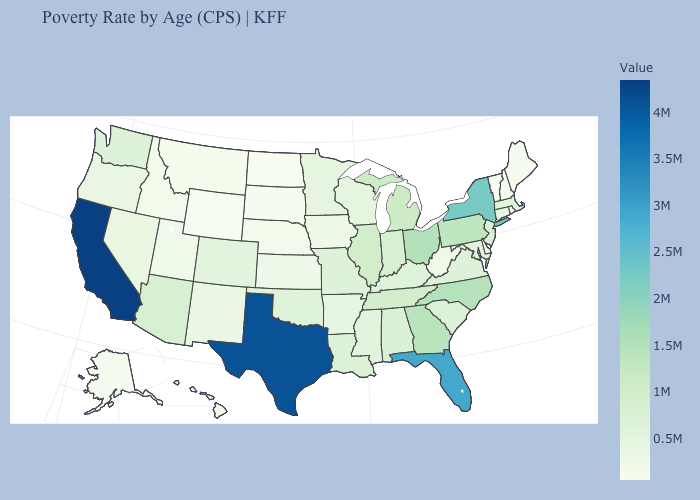Among the states that border Maryland , does Pennsylvania have the highest value?
Keep it brief. Yes. Does Colorado have the highest value in the West?
Give a very brief answer. No. Among the states that border Georgia , does Florida have the highest value?
Keep it brief. Yes. Does California have the highest value in the West?
Write a very short answer. Yes. Does North Dakota have a lower value than California?
Keep it brief. Yes. Among the states that border Massachusetts , which have the lowest value?
Quick response, please. Vermont. Does Alaska have a higher value than Virginia?
Be succinct. No. Does the map have missing data?
Quick response, please. No. 